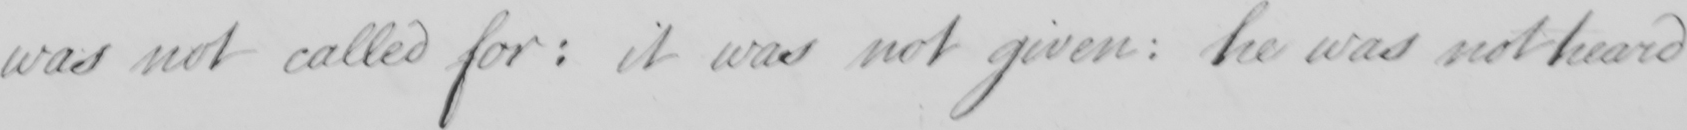What text is written in this handwritten line? was not called for: it was not given: he was not heard 